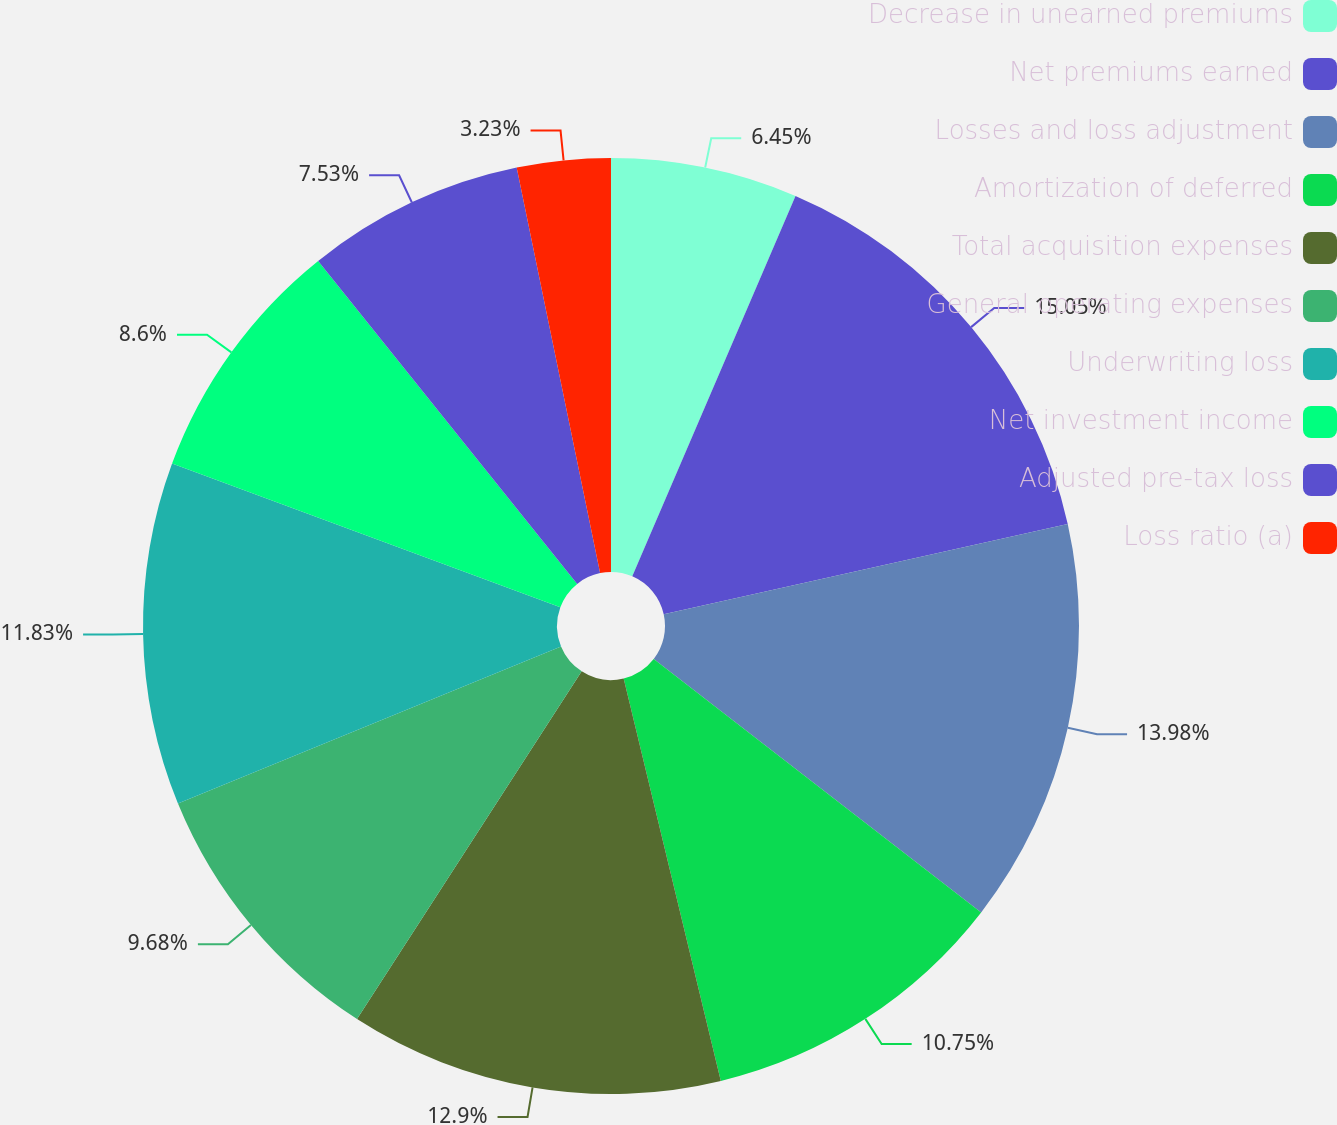Convert chart to OTSL. <chart><loc_0><loc_0><loc_500><loc_500><pie_chart><fcel>Decrease in unearned premiums<fcel>Net premiums earned<fcel>Losses and loss adjustment<fcel>Amortization of deferred<fcel>Total acquisition expenses<fcel>General operating expenses<fcel>Underwriting loss<fcel>Net investment income<fcel>Adjusted pre-tax loss<fcel>Loss ratio (a)<nl><fcel>6.45%<fcel>15.05%<fcel>13.98%<fcel>10.75%<fcel>12.9%<fcel>9.68%<fcel>11.83%<fcel>8.6%<fcel>7.53%<fcel>3.23%<nl></chart> 